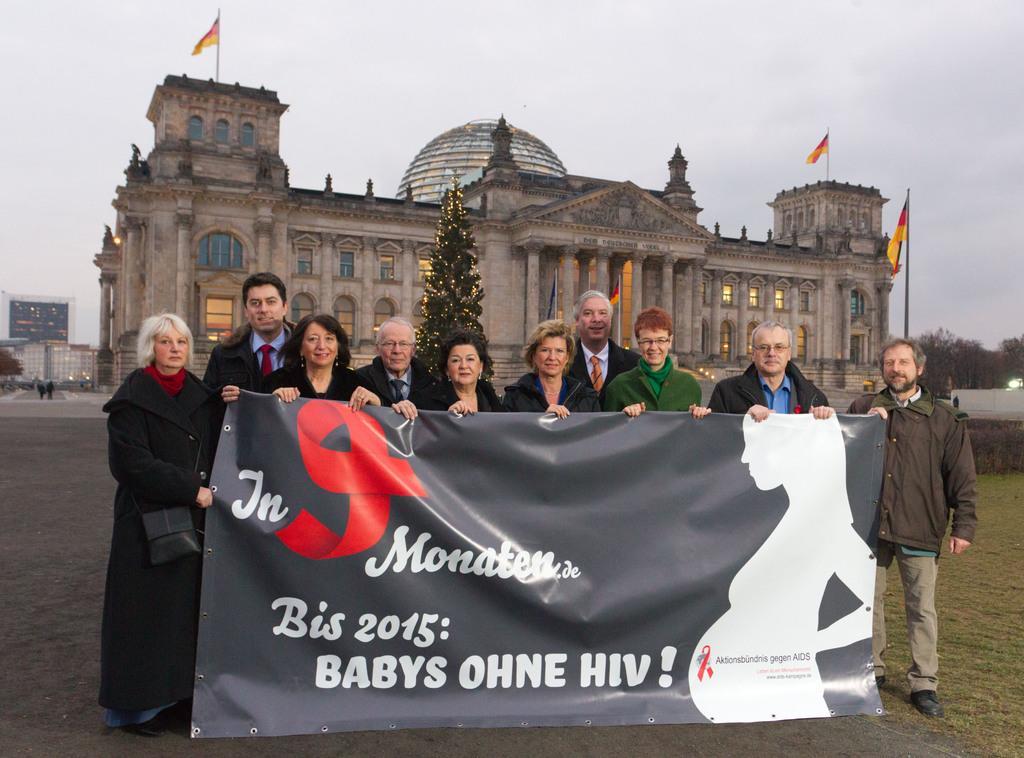How would you summarize this image in a sentence or two? In this image in front there are people holding the banner. Behind them there is a Christmas tree. In the background of the image there are flags, buildings, trees and sky. On the left side of the image there are two people standing on the road. There is a display board on the left side of the image. 